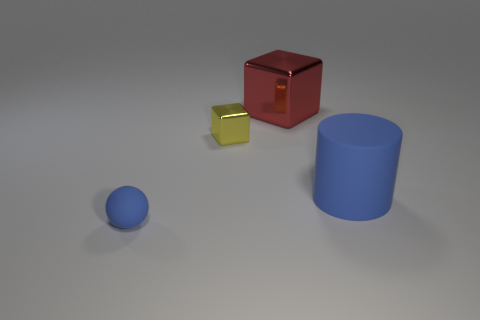Add 1 red cubes. How many objects exist? 5 Subtract all cylinders. How many objects are left? 3 Add 3 small spheres. How many small spheres are left? 4 Add 4 red metal cubes. How many red metal cubes exist? 5 Subtract 0 purple blocks. How many objects are left? 4 Subtract all large red shiny objects. Subtract all large red cubes. How many objects are left? 2 